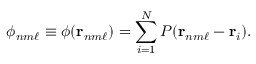<formula> <loc_0><loc_0><loc_500><loc_500>\phi _ { n m \ell } \equiv \phi ( r _ { n m \ell } ) = \sum _ { i = 1 } ^ { N } P ( r _ { n m \ell } - r _ { i } ) .</formula> 